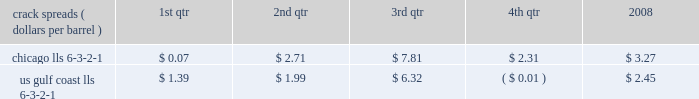Our refining and wholesale marketing gross margin is the difference between the prices of refined products sold and the costs of crude oil and other charge and blendstocks refined , including the costs to transport these inputs to our refineries , the costs of purchased products and manufacturing expenses , including depreciation .
The crack spread is a measure of the difference between market prices for refined products and crude oil , commonly used by the industry as an indicator of the impact of price on the refining margin .
Crack spreads can fluctuate significantly , particularly when prices of refined products do not move in the same relationship as the cost of crude oil .
As a performance benchmark and a comparison with other industry participants , we calculate midwest ( chicago ) and u.s .
Gulf coast crack spreads that we feel most closely track our operations and slate of products .
Posted light louisiana sweet ( 201clls 201d ) prices and a 6-3-2-1 ratio of products ( 6 barrels of crude oil producing 3 barrels of gasoline , 2 barrels of distillate and 1 barrel of residual fuel ) are used for the crack spread calculation .
The table lists calculated average crack spreads by quarter for the midwest ( chicago ) and gulf coast markets in 2008 .
Crack spreads ( dollars per barrel ) 1st qtr 2nd qtr 3rd qtr 4th qtr 2008 .
In addition to the market changes indicated by the crack spreads , our refining and wholesale marketing gross margin is impacted by factors such as the types of crude oil and other charge and blendstocks processed , the selling prices realized for refined products , the impact of commodity derivative instruments used to mitigate price risk and the cost of purchased products for resale .
We process significant amounts of sour crude oil which can enhance our profitability compared to certain of our competitors , as sour crude oil typically can be purchased at a discount to sweet crude oil .
Finally , our refining and wholesale marketing gross margin is impacted by changes in manufacturing costs , which are primarily driven by the level of maintenance activities at the refineries and the price of purchased natural gas used for plant fuel .
Our 2008 refining and wholesale marketing gross margin was the key driver of the 43 percent decrease in rm&t segment income when compared to 2007 .
Our average refining and wholesale marketing gross margin per gallon decreased 37 percent , to 11.66 cents in 2008 from 18.48 cents in 2007 , primarily due to the significant and rapid increases in crude oil prices early in 2008 and lagging wholesale price realizations .
Our retail marketing gross margin for gasoline and distillates , which is the difference between the ultimate price paid by consumers and the cost of refined products , including secondary transportation and consumer excise taxes , also impacts rm&t segment profitability .
While on average demand has been increasing for several years , there are numerous factors including local competition , seasonal demand fluctuations , the available wholesale supply , the level of economic activity in our marketing areas and weather conditions that impact gasoline and distillate demand throughout the year .
In 2008 , demand began to drop due to the combination of significant increases in retail petroleum prices and a broad slowdown in general activity .
The gross margin on merchandise sold at retail outlets has historically been more constant .
The profitability of our pipeline transportation operations is primarily dependent on the volumes shipped through our crude oil and refined products pipelines .
The volume of crude oil that we transport is directly affected by the supply of , and refiner demand for , crude oil in the markets served directly by our crude oil pipelines .
Key factors in this supply and demand balance are the production levels of crude oil by producers , the availability and cost of alternative modes of transportation , and refinery and transportation system maintenance levels .
The volume of refined products that we transport is directly affected by the production levels of , and user demand for , refined products in the markets served by our refined product pipelines .
In most of our markets , demand for gasoline peaks during the summer and declines during the fall and winter months , whereas distillate demand is more ratable throughout the year .
As with crude oil , other transportation alternatives and system maintenance levels influence refined product movements .
Integrated gas our integrated gas strategy is to link stranded natural gas resources with areas where a supply gap is emerging due to declining production and growing demand .
Our integrated gas operations include marketing and transportation of products manufactured from natural gas , such as lng and methanol , primarily in the u.s. , europe and west africa .
Our most significant lng investment is our 60 percent ownership in a production facility in equatorial guinea , which sells lng under a long-term contract at prices tied to henry hub natural gas prices .
In 2008 , its .
How much higher was the u.s gulf coast crack spread than the chicago crack spread in the first quarter of 2008? 
Computations: (1.39 - 0.07)
Answer: 1.32. 